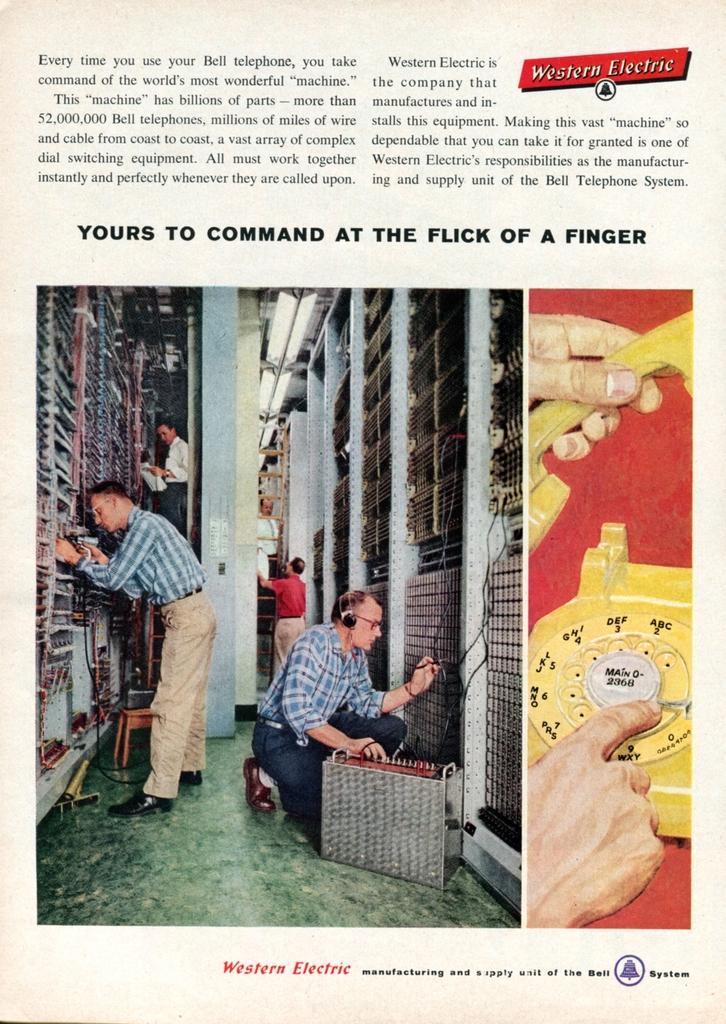Please provide a concise description of this image. In this image I can see the collage image. I can see few people are holding something. I can see few objects in the racks and one person is holding yellow color telephone and something is written on the image. 